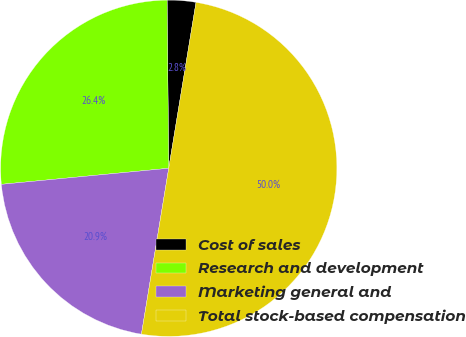Convert chart to OTSL. <chart><loc_0><loc_0><loc_500><loc_500><pie_chart><fcel>Cost of sales<fcel>Research and development<fcel>Marketing general and<fcel>Total stock-based compensation<nl><fcel>2.75%<fcel>26.37%<fcel>20.88%<fcel>50.0%<nl></chart> 